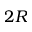<formula> <loc_0><loc_0><loc_500><loc_500>2 R</formula> 